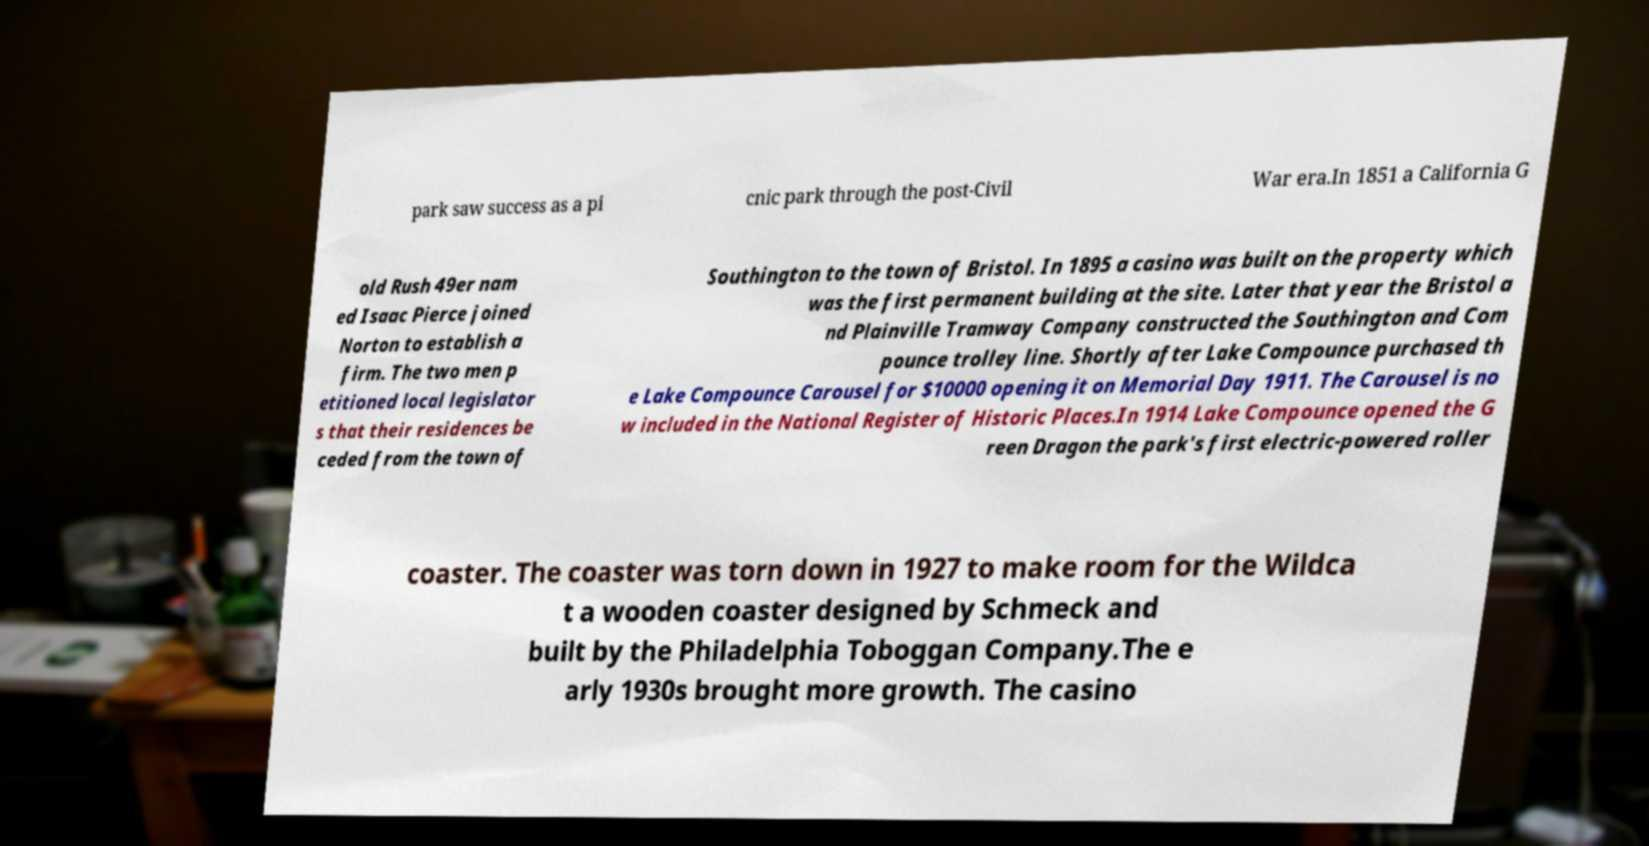Could you extract and type out the text from this image? park saw success as a pi cnic park through the post-Civil War era.In 1851 a California G old Rush 49er nam ed Isaac Pierce joined Norton to establish a firm. The two men p etitioned local legislator s that their residences be ceded from the town of Southington to the town of Bristol. In 1895 a casino was built on the property which was the first permanent building at the site. Later that year the Bristol a nd Plainville Tramway Company constructed the Southington and Com pounce trolley line. Shortly after Lake Compounce purchased th e Lake Compounce Carousel for $10000 opening it on Memorial Day 1911. The Carousel is no w included in the National Register of Historic Places.In 1914 Lake Compounce opened the G reen Dragon the park's first electric-powered roller coaster. The coaster was torn down in 1927 to make room for the Wildca t a wooden coaster designed by Schmeck and built by the Philadelphia Toboggan Company.The e arly 1930s brought more growth. The casino 